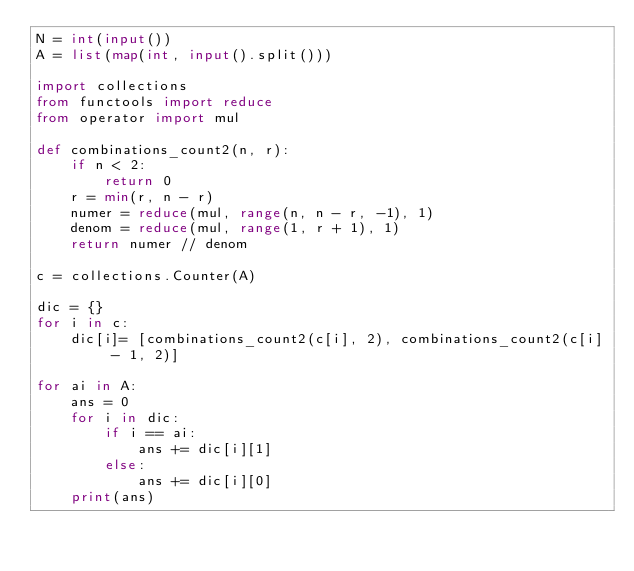Convert code to text. <code><loc_0><loc_0><loc_500><loc_500><_Python_>N = int(input())
A = list(map(int, input().split()))
 
import collections
from functools import reduce
from operator import mul

def combinations_count2(n, r):
    if n < 2:
        return 0
    r = min(r, n - r)
    numer = reduce(mul, range(n, n - r, -1), 1)
    denom = reduce(mul, range(1, r + 1), 1)
    return numer // denom

c = collections.Counter(A)

dic = {}
for i in c:
    dic[i]= [combinations_count2(c[i], 2), combinations_count2(c[i] - 1, 2)]

for ai in A:
    ans = 0
    for i in dic:
        if i == ai:
            ans += dic[i][1]
        else:
            ans += dic[i][0]
    print(ans)</code> 